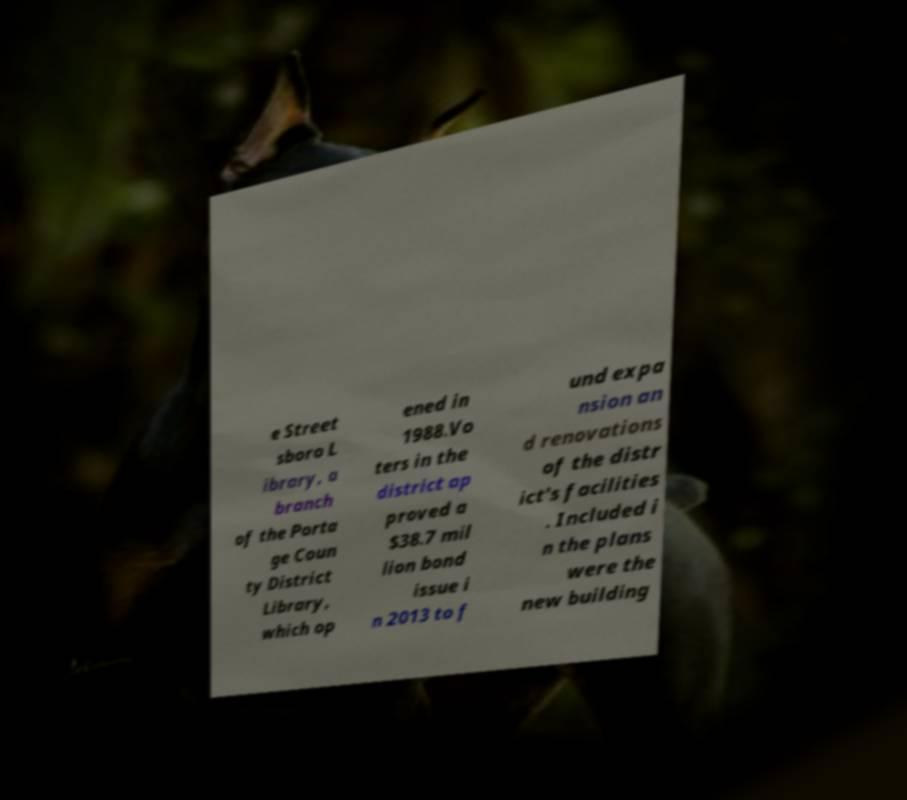Could you assist in decoding the text presented in this image and type it out clearly? e Street sboro L ibrary, a branch of the Porta ge Coun ty District Library, which op ened in 1988.Vo ters in the district ap proved a $38.7 mil lion bond issue i n 2013 to f und expa nsion an d renovations of the distr ict's facilities . Included i n the plans were the new building 